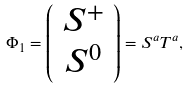Convert formula to latex. <formula><loc_0><loc_0><loc_500><loc_500>\Phi _ { 1 } = \left ( \begin{array} { c } S ^ { + } \\ S ^ { 0 } \end{array} \right ) = S ^ { a } T ^ { a } ,</formula> 